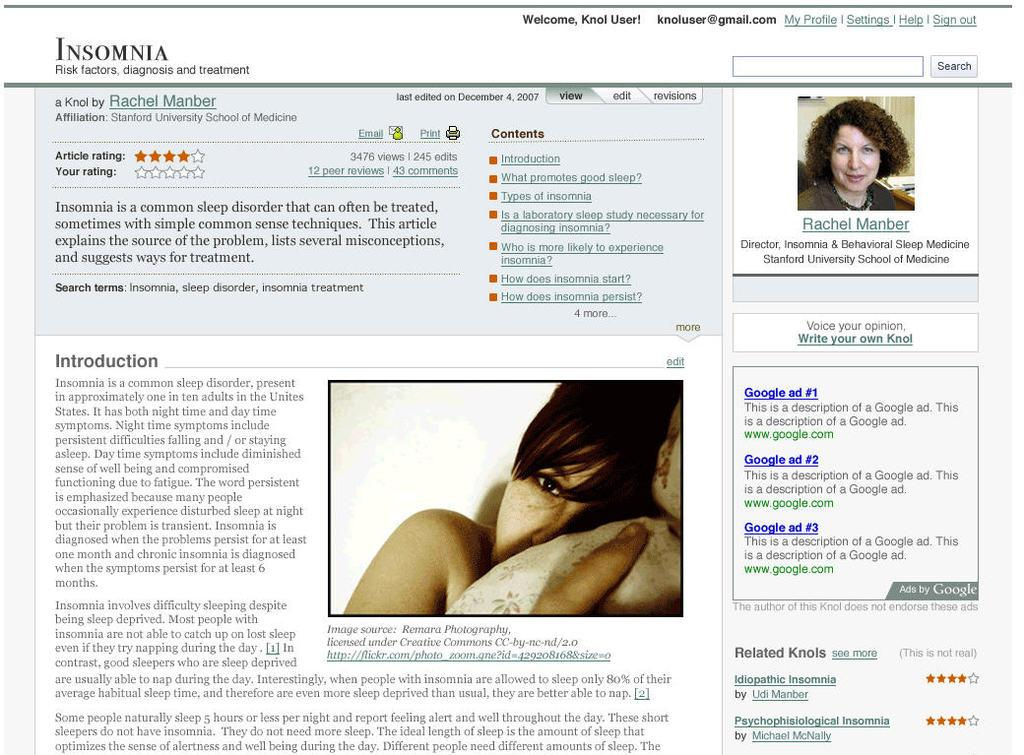What type of content is displayed in the image? The image is a website page. Can you describe the people present on the page? There are two women on the page, one in the top right corner and the other in the center. What else can be found on the website page besides the images of the women? There is text on the page. What type of nut is being used as a prop by the woman in the center of the image? There is no nut present in the image; it is a website page featuring two women and text. 